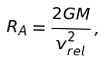<formula> <loc_0><loc_0><loc_500><loc_500>R _ { A } = \frac { 2 G M } { v _ { r e l } ^ { 2 } } \, ,</formula> 